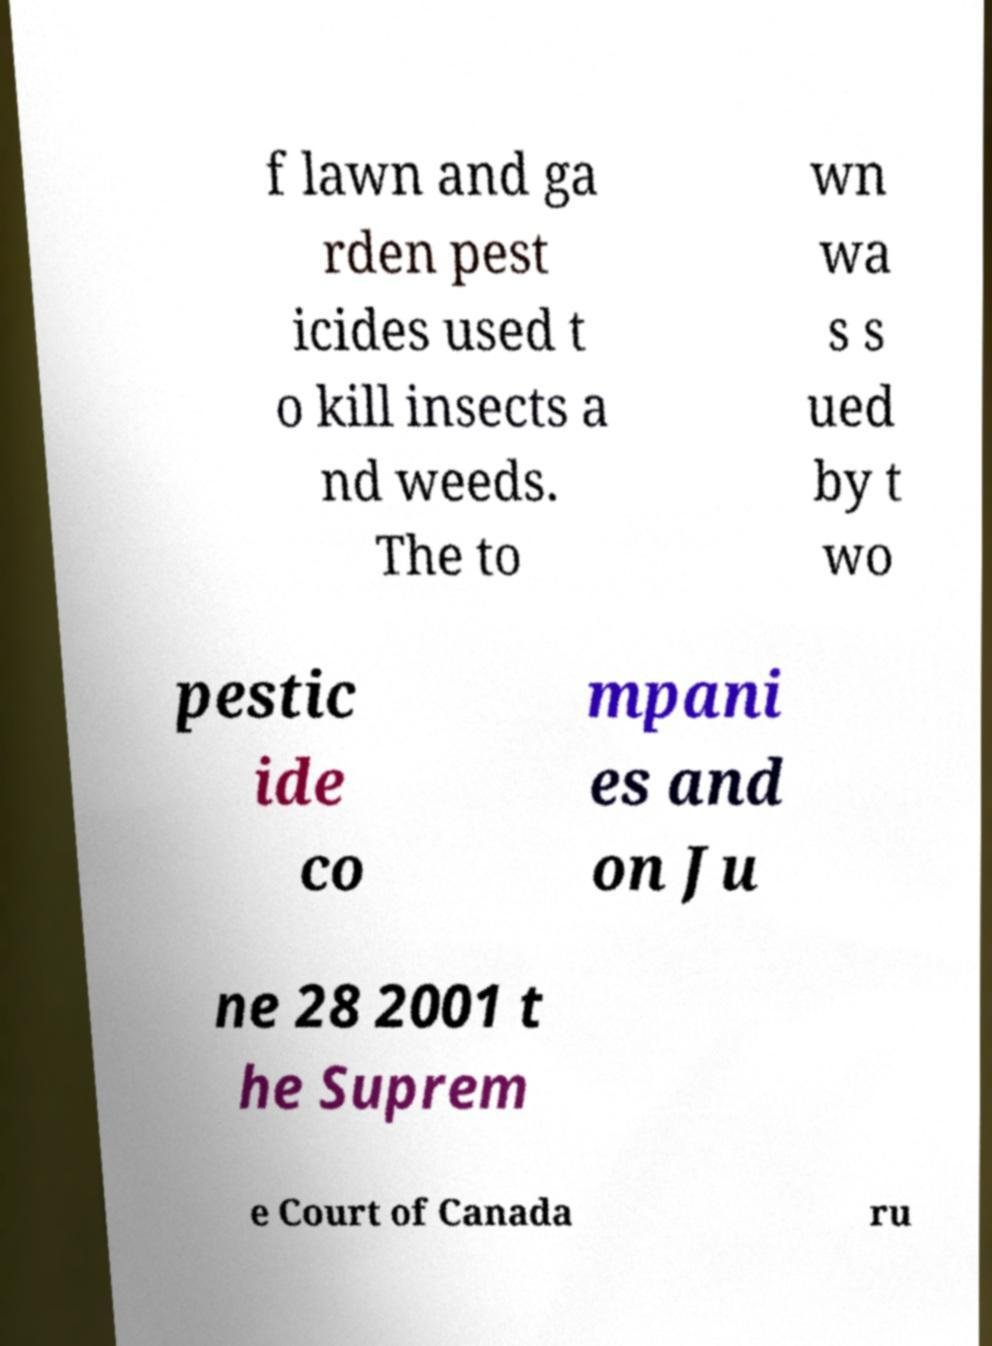Could you assist in decoding the text presented in this image and type it out clearly? f lawn and ga rden pest icides used t o kill insects a nd weeds. The to wn wa s s ued by t wo pestic ide co mpani es and on Ju ne 28 2001 t he Suprem e Court of Canada ru 